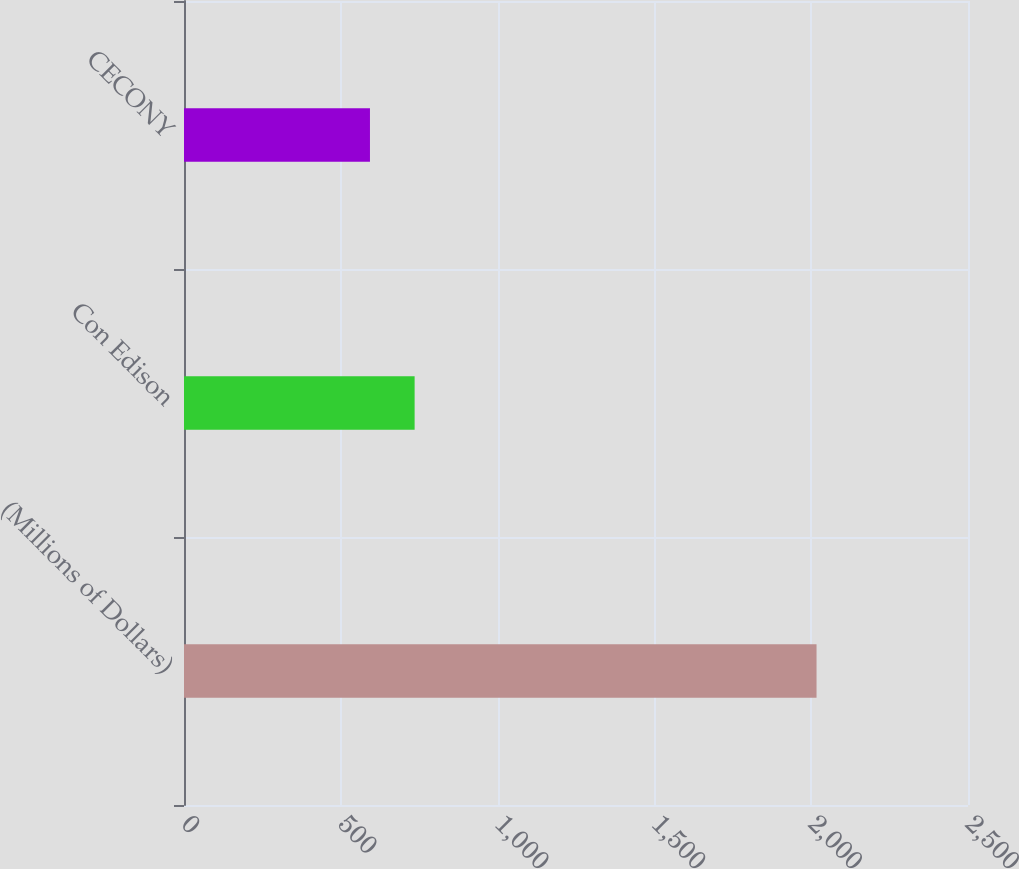Convert chart to OTSL. <chart><loc_0><loc_0><loc_500><loc_500><bar_chart><fcel>(Millions of Dollars)<fcel>Con Edison<fcel>CECONY<nl><fcel>2017<fcel>735.4<fcel>593<nl></chart> 